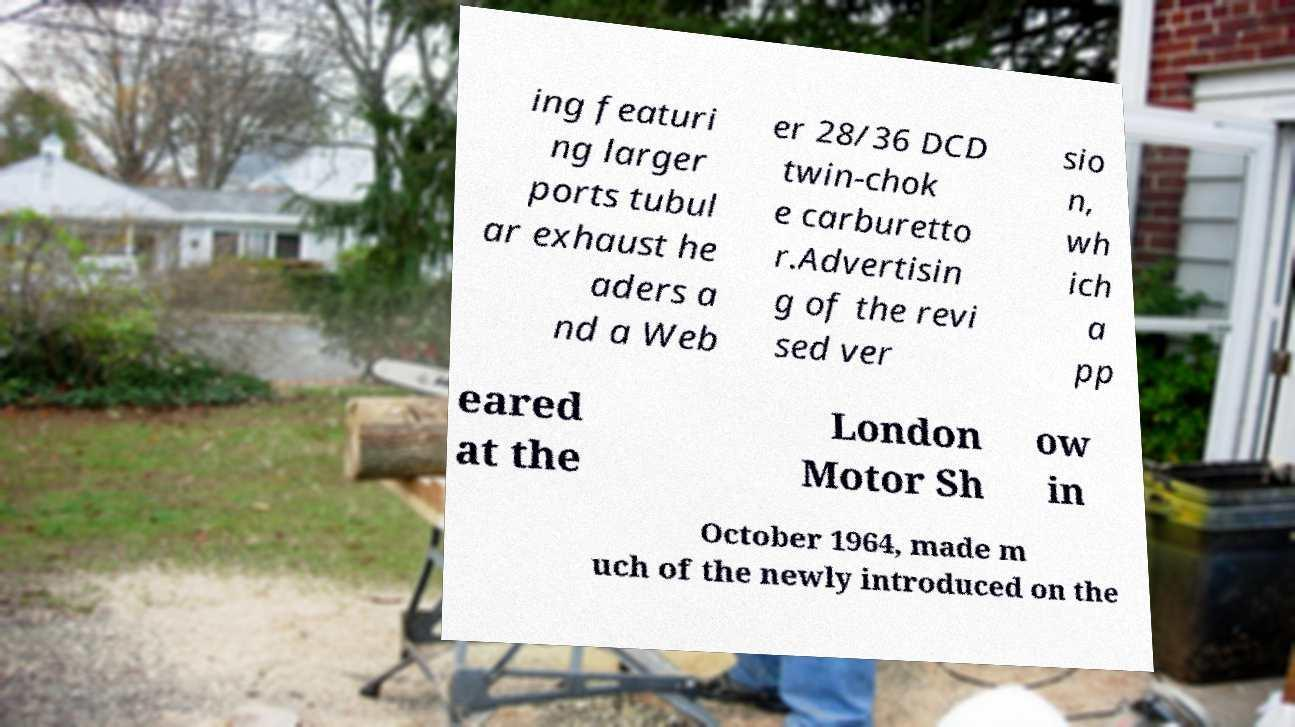Please identify and transcribe the text found in this image. ing featuri ng larger ports tubul ar exhaust he aders a nd a Web er 28/36 DCD twin-chok e carburetto r.Advertisin g of the revi sed ver sio n, wh ich a pp eared at the London Motor Sh ow in October 1964, made m uch of the newly introduced on the 